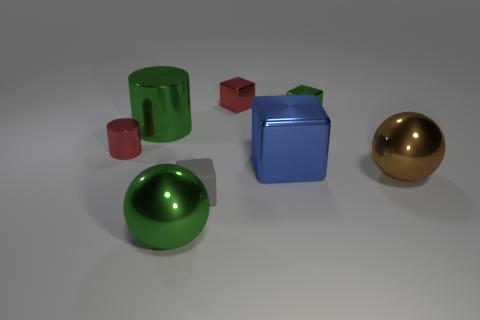Are the tiny green thing and the red cube made of the same material?
Keep it short and to the point. Yes. There is a tiny red metal thing in front of the tiny red metallic thing on the right side of the large green ball; what number of balls are on the left side of it?
Make the answer very short. 0. Are there any large blue cylinders made of the same material as the tiny green thing?
Your answer should be compact. No. There is a block that is the same color as the large metal cylinder; what size is it?
Give a very brief answer. Small. Is the number of big objects less than the number of small red metal cylinders?
Offer a very short reply. No. There is a large metallic object in front of the tiny rubber object; is it the same color as the tiny cylinder?
Provide a succinct answer. No. The green object left of the large thing that is in front of the big shiny sphere on the right side of the tiny gray matte thing is made of what material?
Provide a short and direct response. Metal. Are there any matte objects of the same color as the tiny matte cube?
Provide a short and direct response. No. Is the number of metallic things that are behind the large green cylinder less than the number of small rubber objects?
Ensure brevity in your answer.  No. There is a green shiny object in front of the gray matte cube; is it the same size as the small green thing?
Your answer should be very brief. No. 